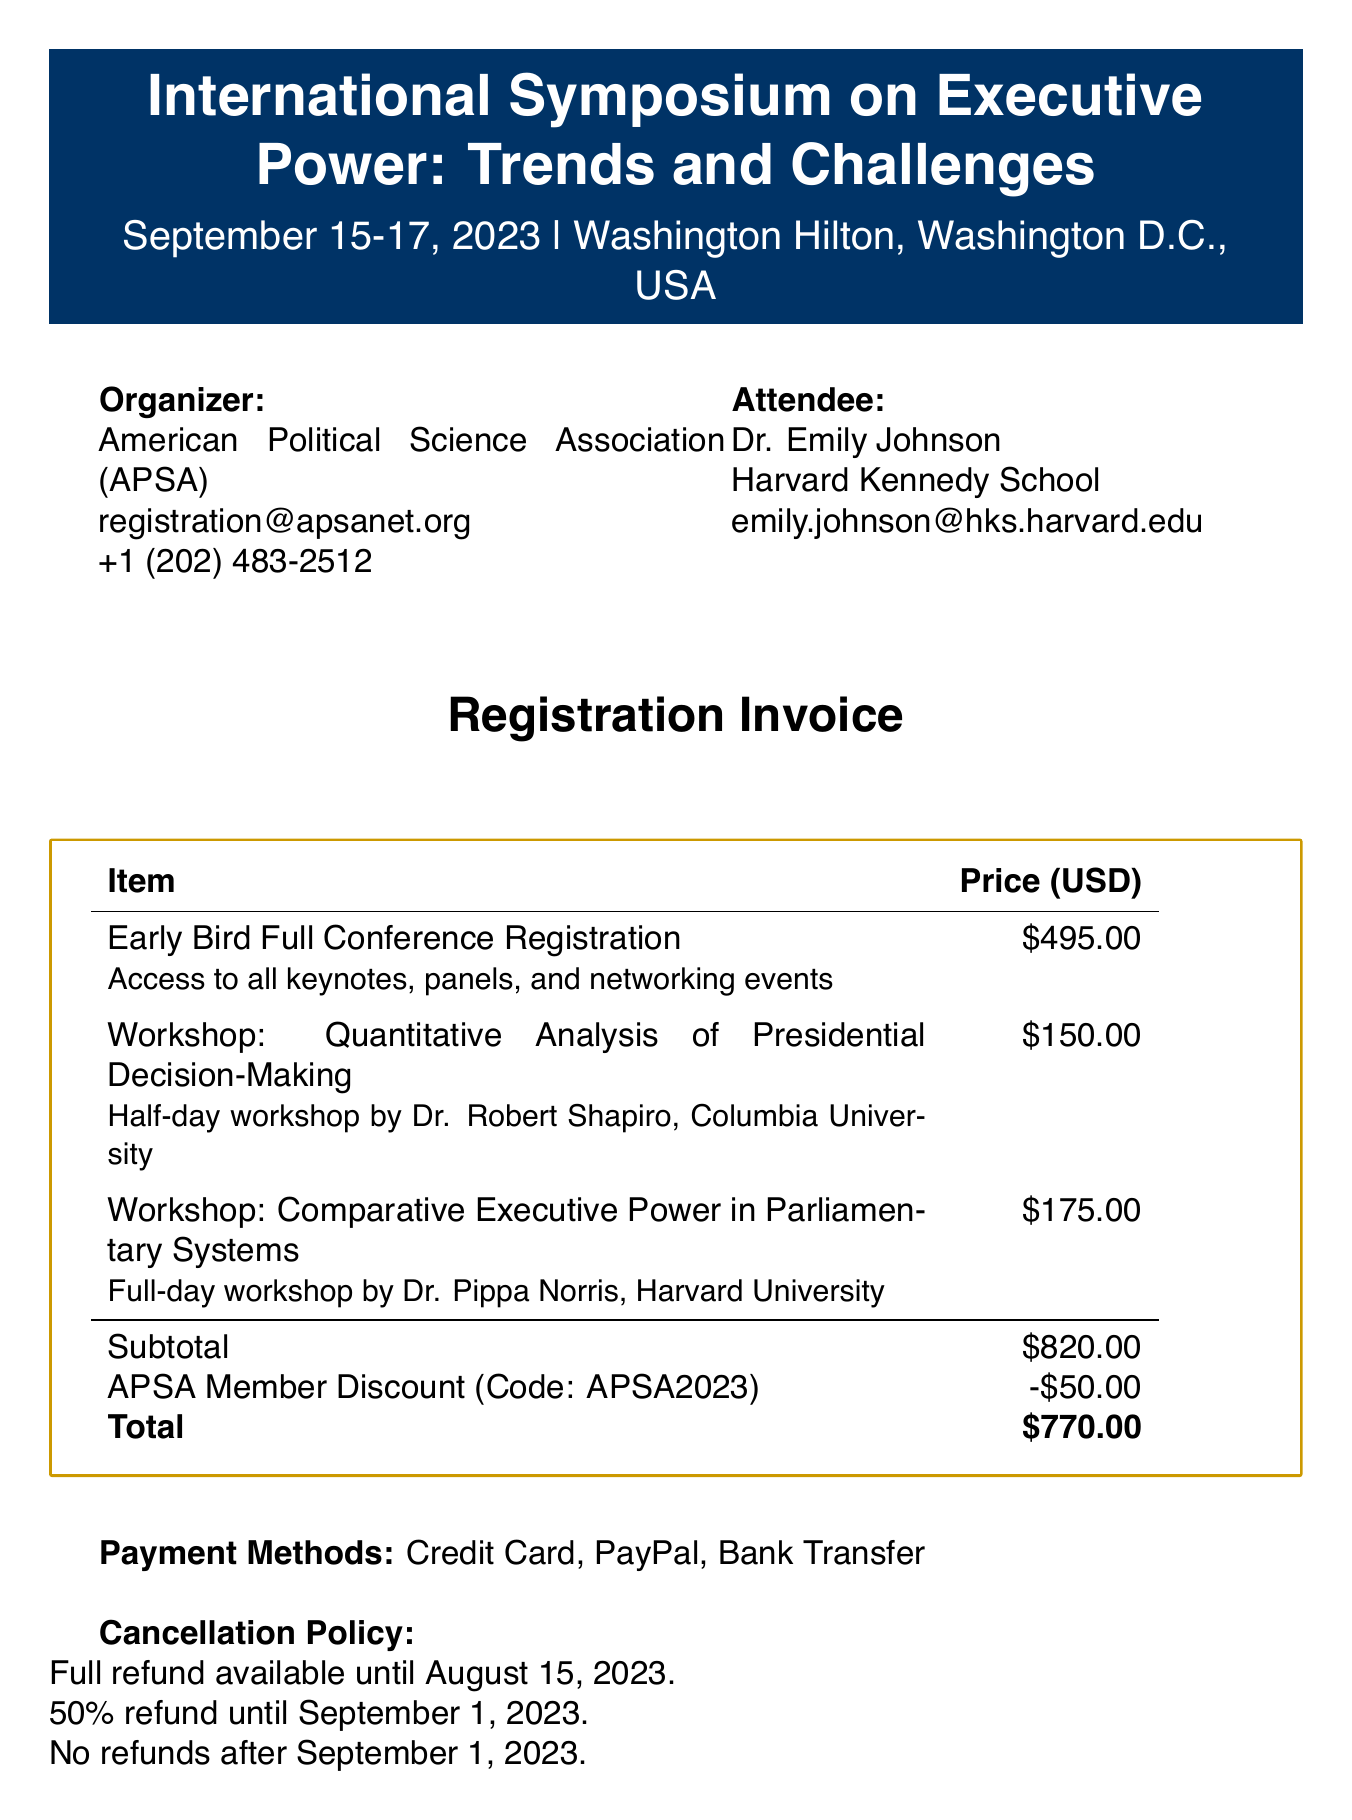What is the name of the symposium? The document specifies the event as the "International Symposium on Executive Power: Trends and Challenges."
Answer: International Symposium on Executive Power: Trends and Challenges Who is the organizer of the event? The document states that the event is organized by the American Political Science Association (APSA).
Answer: American Political Science Association (APSA) What is the date of the symposium? The document mentions that the symposium takes place from September 15-17, 2023.
Answer: September 15-17, 2023 What is the price of the Early Bird Full Conference registration? The document indicates that the Early Bird Full Conference registration is priced at $495.
Answer: $495 What is the total amount after the APSA Member Discount? The subtotal is $820, and the APSA Member Discount of $50 is applied, leading to the total of $770.
Answer: $770 Who is the instructor for the workshop on Quantitative Analysis? The document lists Dr. Robert Shapiro from Columbia University as the instructor for this workshop.
Answer: Dr. Robert Shapiro, Columbia University What is the cancellation policy for refunds? According to the document, the full refund is available until August 15, 2023, and no refunds are available after September 1, 2023.
Answer: Full refund until August 15, 2023 Is there a student discount available? The document indicates the availability of a Student Discount amounting to $100 with the code STUDENT2023.
Answer: Yes What is one of the special events mentioned in the document? The document refers to a special event called the "Presidential Roundtable: The Future of Executive Power."
Answer: Presidential Roundtable: The Future of Executive Power 